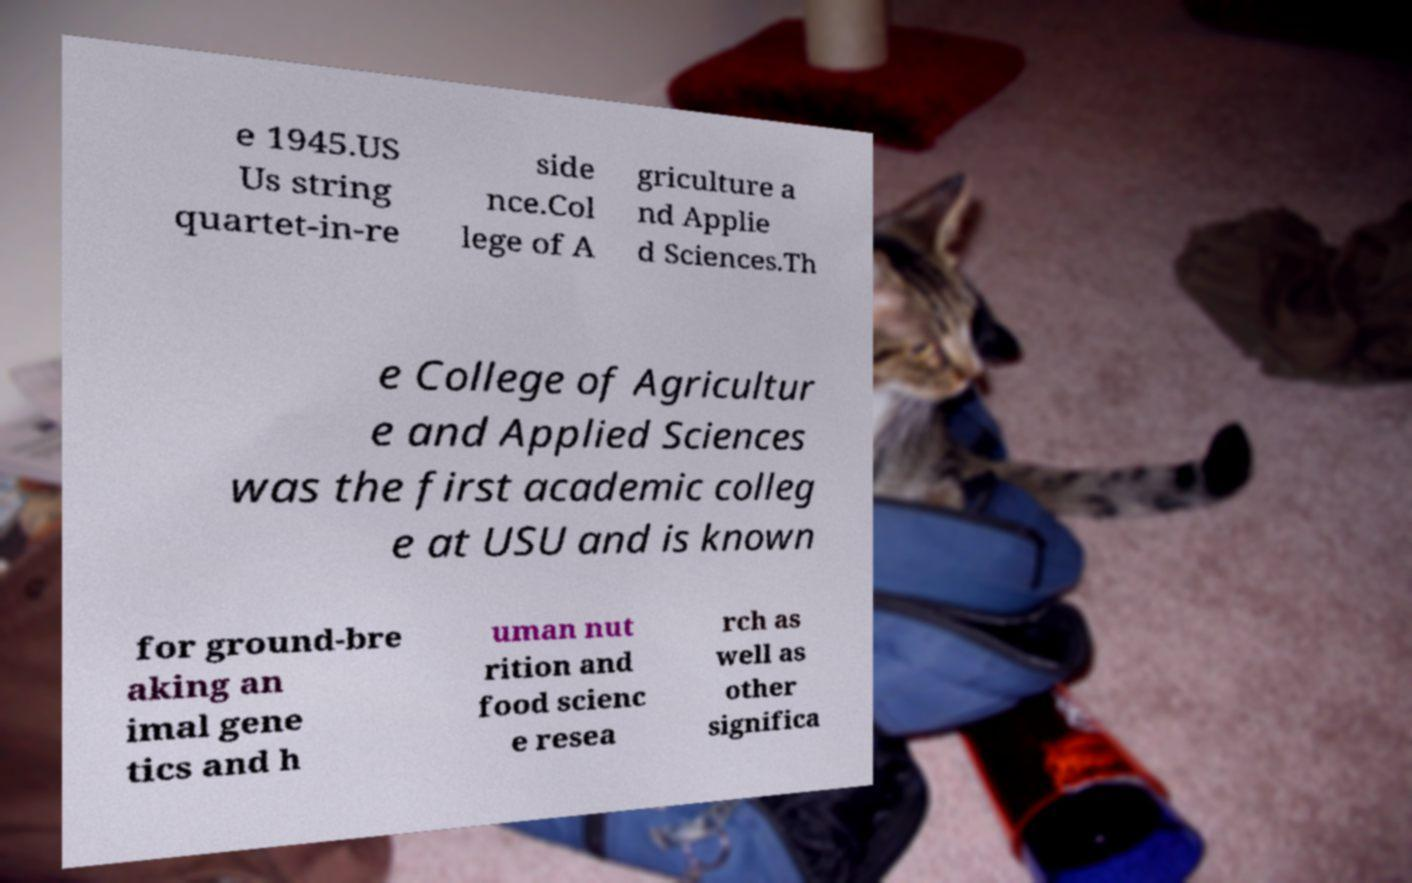There's text embedded in this image that I need extracted. Can you transcribe it verbatim? e 1945.US Us string quartet-in-re side nce.Col lege of A griculture a nd Applie d Sciences.Th e College of Agricultur e and Applied Sciences was the first academic colleg e at USU and is known for ground-bre aking an imal gene tics and h uman nut rition and food scienc e resea rch as well as other significa 